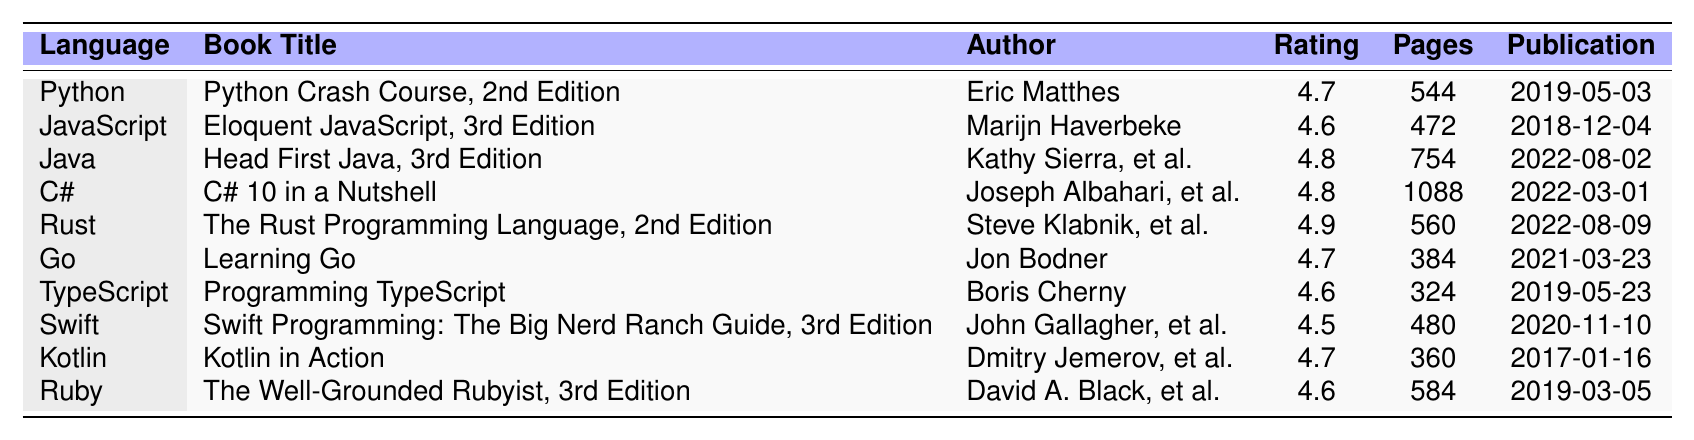What is the highest-rated book in the table? By reviewing the "Rating" column, the highest value is 4.9, which corresponds to "The Rust Programming Language, 2nd Edition" by Steve Klabnik and Carol Nichols.
Answer: The Rust Programming Language, 2nd Edition How many pages does the book "Head First Java, 3rd Edition" have? Looking at the "Pages" column for the row where the "Book Title" is "Head First Java, 3rd Edition", it shows 754 pages.
Answer: 754 Which programming language has the latest publication date? The publication dates in the table are compared. The latest date is "2022-08-09" for "The Rust Programming Language, 2nd Edition".
Answer: Rust Is there a book on Kotlin in the table? The "Programming Language" column includes Kotlin, and it lists "Kotlin in Action" by Dmitry Jemerov and Svetlana Isakova, confirming the presence of a Kotlin book.
Answer: Yes What is the average number of pages for the books listed? The total number of pages is calculated as 544 + 472 + 754 + 1088 + 560 + 384 + 324 + 480 + 360 + 584 = 4760. There are 10 books, so the average is 4760 / 10 = 476.
Answer: 476 Which book has the lowest rating and what is that rating? By analyzing the "Rating" column, the lowest rating among the entries is 4.5, corresponding to "Swift Programming: The Big Nerd Ranch Guide, 3rd Edition".
Answer: 4.5 for Swift Programming: The Big Nerd Ranch Guide, 3rd Edition How many authors contributed to the writing of "C# 10 in a Nutshell"? Looking at the "Author" column, it specifies two authors: Joseph Albahari and Eric Johannsen.
Answer: 2 What is the total number of ratings for the books listed? The ratings are simply totalled up: 4.7 + 4.6 + 4.8 + 4.8 + 4.9 + 4.7 + 4.6 + 4.5 + 4.7 + 4.6 = 47.8.
Answer: 47.8 Which book has the most pages, and how many pages does it have? In the "Pages" column, "C# 10 in a Nutshell" shows the highest page count at 1088 pages.
Answer: C# 10 in a Nutshell with 1088 pages What percentage of the books in the table were published in 2022? There are 3 books published in 2022 ("Head First Java, 3rd Edition", "C# 10 in a Nutshell", and "The Rust Programming Language, 2nd Edition") out of 10 total books. The percentage is (3/10) * 100 = 30%.
Answer: 30% 